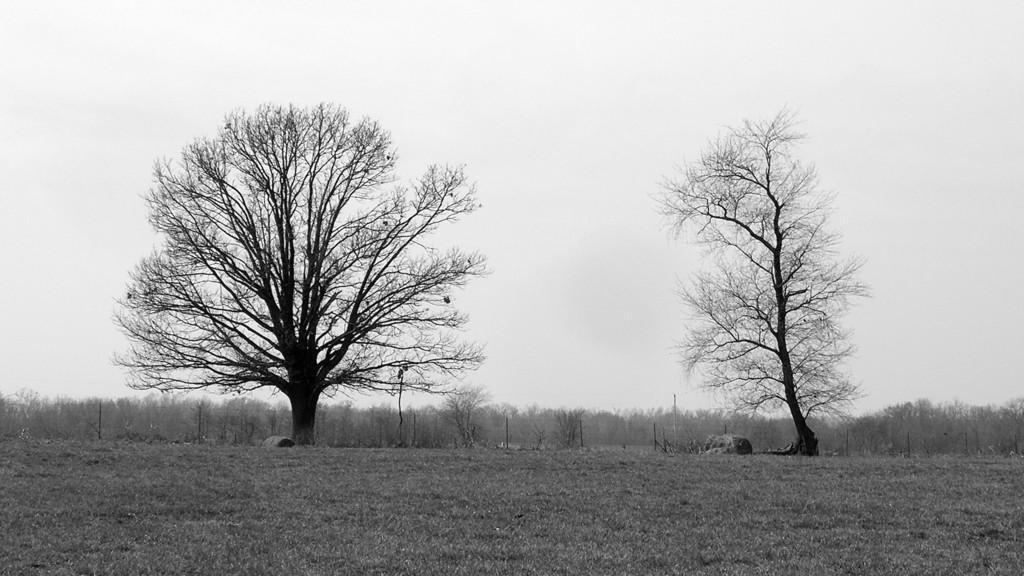How would you summarize this image in a sentence or two? In this picture I can see few trees in the middle, at the top there is the sky. This image is in black and white color. 